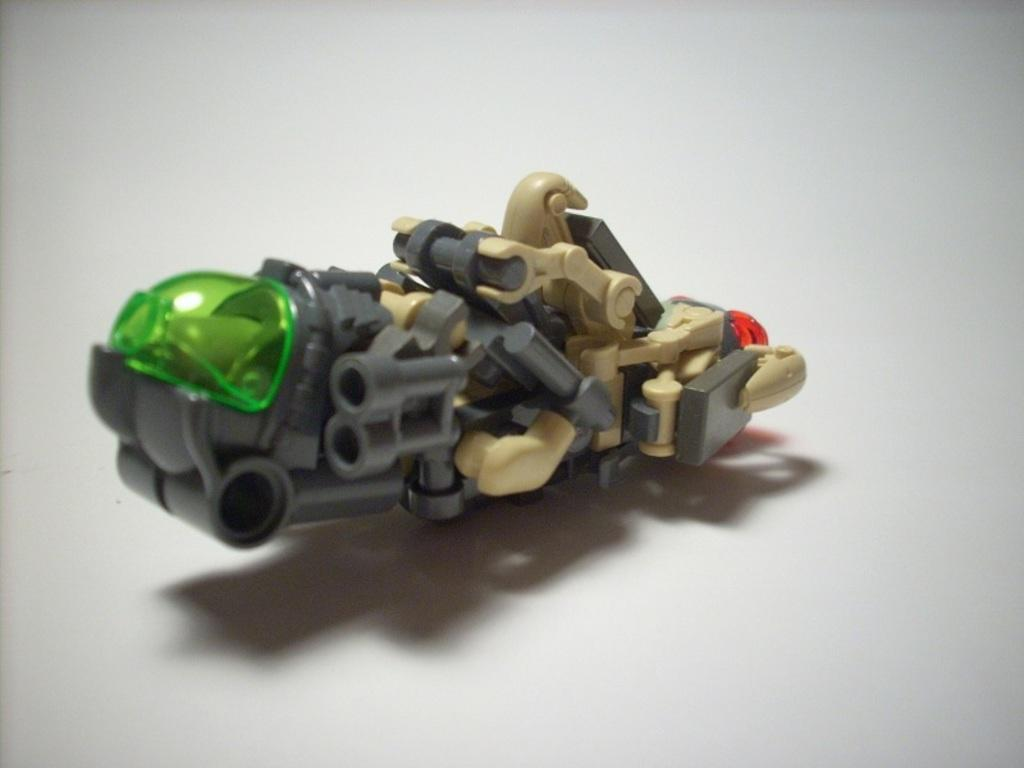What object can be seen in the image? There is a toy in the image. What is the color of the surface the toy is on? The toy is on a white-colored surface. What type of steel is being tested in the market in the image? There is no reference to steel or a market in the image, so it is not possible to answer that question. 